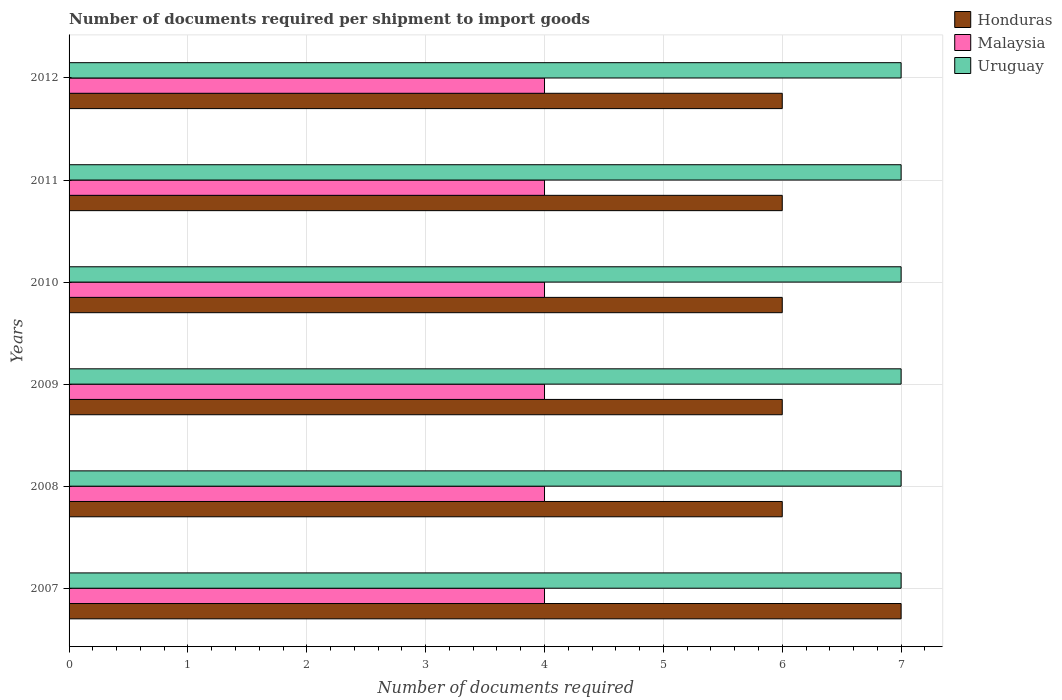How many different coloured bars are there?
Give a very brief answer. 3. Are the number of bars per tick equal to the number of legend labels?
Offer a very short reply. Yes. How many bars are there on the 2nd tick from the top?
Provide a succinct answer. 3. In how many cases, is the number of bars for a given year not equal to the number of legend labels?
Give a very brief answer. 0. What is the number of documents required per shipment to import goods in Malaysia in 2009?
Provide a succinct answer. 4. Across all years, what is the maximum number of documents required per shipment to import goods in Honduras?
Provide a short and direct response. 7. In which year was the number of documents required per shipment to import goods in Uruguay maximum?
Provide a succinct answer. 2007. In which year was the number of documents required per shipment to import goods in Honduras minimum?
Keep it short and to the point. 2008. What is the total number of documents required per shipment to import goods in Malaysia in the graph?
Ensure brevity in your answer.  24. What is the difference between the number of documents required per shipment to import goods in Honduras in 2008 and that in 2012?
Provide a succinct answer. 0. What is the difference between the number of documents required per shipment to import goods in Uruguay in 2010 and the number of documents required per shipment to import goods in Honduras in 2009?
Offer a terse response. 1. What is the average number of documents required per shipment to import goods in Uruguay per year?
Offer a terse response. 7. In the year 2011, what is the difference between the number of documents required per shipment to import goods in Malaysia and number of documents required per shipment to import goods in Honduras?
Ensure brevity in your answer.  -2. Is the difference between the number of documents required per shipment to import goods in Malaysia in 2009 and 2011 greater than the difference between the number of documents required per shipment to import goods in Honduras in 2009 and 2011?
Offer a very short reply. No. What is the difference between the highest and the lowest number of documents required per shipment to import goods in Honduras?
Your answer should be very brief. 1. Is the sum of the number of documents required per shipment to import goods in Uruguay in 2011 and 2012 greater than the maximum number of documents required per shipment to import goods in Honduras across all years?
Your response must be concise. Yes. What does the 1st bar from the top in 2010 represents?
Make the answer very short. Uruguay. What does the 1st bar from the bottom in 2007 represents?
Your answer should be very brief. Honduras. How many bars are there?
Offer a terse response. 18. Are all the bars in the graph horizontal?
Your answer should be compact. Yes. How many years are there in the graph?
Your response must be concise. 6. What is the difference between two consecutive major ticks on the X-axis?
Your answer should be very brief. 1. Are the values on the major ticks of X-axis written in scientific E-notation?
Your answer should be compact. No. Where does the legend appear in the graph?
Your answer should be compact. Top right. What is the title of the graph?
Your answer should be very brief. Number of documents required per shipment to import goods. Does "High income" appear as one of the legend labels in the graph?
Your answer should be compact. No. What is the label or title of the X-axis?
Your answer should be compact. Number of documents required. What is the Number of documents required of Honduras in 2007?
Give a very brief answer. 7. What is the Number of documents required of Uruguay in 2007?
Your answer should be compact. 7. What is the Number of documents required in Malaysia in 2008?
Your answer should be very brief. 4. What is the Number of documents required of Honduras in 2009?
Keep it short and to the point. 6. What is the Number of documents required in Malaysia in 2009?
Offer a terse response. 4. What is the Number of documents required in Uruguay in 2009?
Offer a terse response. 7. What is the Number of documents required of Malaysia in 2010?
Make the answer very short. 4. What is the Number of documents required in Uruguay in 2010?
Your answer should be compact. 7. What is the Number of documents required of Honduras in 2011?
Offer a terse response. 6. What is the Number of documents required in Malaysia in 2011?
Ensure brevity in your answer.  4. What is the Number of documents required in Uruguay in 2011?
Provide a short and direct response. 7. What is the Number of documents required of Malaysia in 2012?
Offer a very short reply. 4. What is the Number of documents required of Uruguay in 2012?
Make the answer very short. 7. Across all years, what is the maximum Number of documents required in Honduras?
Your answer should be very brief. 7. Across all years, what is the maximum Number of documents required in Malaysia?
Give a very brief answer. 4. Across all years, what is the minimum Number of documents required in Malaysia?
Your response must be concise. 4. What is the difference between the Number of documents required of Honduras in 2007 and that in 2008?
Your answer should be compact. 1. What is the difference between the Number of documents required of Malaysia in 2007 and that in 2008?
Give a very brief answer. 0. What is the difference between the Number of documents required in Uruguay in 2007 and that in 2008?
Your response must be concise. 0. What is the difference between the Number of documents required in Malaysia in 2007 and that in 2009?
Provide a short and direct response. 0. What is the difference between the Number of documents required of Uruguay in 2007 and that in 2009?
Offer a terse response. 0. What is the difference between the Number of documents required of Honduras in 2007 and that in 2010?
Provide a succinct answer. 1. What is the difference between the Number of documents required of Malaysia in 2007 and that in 2010?
Ensure brevity in your answer.  0. What is the difference between the Number of documents required in Honduras in 2007 and that in 2011?
Your answer should be very brief. 1. What is the difference between the Number of documents required of Malaysia in 2007 and that in 2011?
Your response must be concise. 0. What is the difference between the Number of documents required of Malaysia in 2007 and that in 2012?
Offer a very short reply. 0. What is the difference between the Number of documents required of Uruguay in 2007 and that in 2012?
Provide a short and direct response. 0. What is the difference between the Number of documents required of Honduras in 2008 and that in 2009?
Provide a short and direct response. 0. What is the difference between the Number of documents required of Uruguay in 2008 and that in 2009?
Provide a short and direct response. 0. What is the difference between the Number of documents required of Honduras in 2008 and that in 2010?
Make the answer very short. 0. What is the difference between the Number of documents required in Honduras in 2008 and that in 2011?
Offer a very short reply. 0. What is the difference between the Number of documents required in Uruguay in 2008 and that in 2011?
Offer a very short reply. 0. What is the difference between the Number of documents required in Malaysia in 2008 and that in 2012?
Keep it short and to the point. 0. What is the difference between the Number of documents required in Uruguay in 2008 and that in 2012?
Your answer should be very brief. 0. What is the difference between the Number of documents required of Malaysia in 2009 and that in 2010?
Your answer should be very brief. 0. What is the difference between the Number of documents required of Uruguay in 2009 and that in 2010?
Provide a short and direct response. 0. What is the difference between the Number of documents required in Malaysia in 2009 and that in 2011?
Your answer should be very brief. 0. What is the difference between the Number of documents required in Uruguay in 2009 and that in 2011?
Offer a very short reply. 0. What is the difference between the Number of documents required in Honduras in 2009 and that in 2012?
Give a very brief answer. 0. What is the difference between the Number of documents required of Honduras in 2010 and that in 2011?
Offer a terse response. 0. What is the difference between the Number of documents required of Malaysia in 2010 and that in 2011?
Keep it short and to the point. 0. What is the difference between the Number of documents required of Uruguay in 2010 and that in 2011?
Your answer should be compact. 0. What is the difference between the Number of documents required of Malaysia in 2010 and that in 2012?
Ensure brevity in your answer.  0. What is the difference between the Number of documents required of Uruguay in 2010 and that in 2012?
Provide a succinct answer. 0. What is the difference between the Number of documents required in Uruguay in 2011 and that in 2012?
Your answer should be compact. 0. What is the difference between the Number of documents required of Honduras in 2007 and the Number of documents required of Uruguay in 2008?
Give a very brief answer. 0. What is the difference between the Number of documents required of Honduras in 2007 and the Number of documents required of Malaysia in 2009?
Offer a terse response. 3. What is the difference between the Number of documents required of Honduras in 2007 and the Number of documents required of Uruguay in 2009?
Keep it short and to the point. 0. What is the difference between the Number of documents required of Honduras in 2007 and the Number of documents required of Malaysia in 2011?
Your response must be concise. 3. What is the difference between the Number of documents required of Malaysia in 2007 and the Number of documents required of Uruguay in 2011?
Provide a succinct answer. -3. What is the difference between the Number of documents required of Honduras in 2007 and the Number of documents required of Malaysia in 2012?
Offer a very short reply. 3. What is the difference between the Number of documents required of Honduras in 2008 and the Number of documents required of Uruguay in 2009?
Provide a succinct answer. -1. What is the difference between the Number of documents required in Honduras in 2008 and the Number of documents required in Uruguay in 2011?
Provide a succinct answer. -1. What is the difference between the Number of documents required in Malaysia in 2008 and the Number of documents required in Uruguay in 2011?
Your response must be concise. -3. What is the difference between the Number of documents required in Honduras in 2008 and the Number of documents required in Uruguay in 2012?
Your answer should be very brief. -1. What is the difference between the Number of documents required of Honduras in 2009 and the Number of documents required of Malaysia in 2010?
Give a very brief answer. 2. What is the difference between the Number of documents required in Honduras in 2009 and the Number of documents required in Uruguay in 2010?
Offer a terse response. -1. What is the difference between the Number of documents required of Malaysia in 2009 and the Number of documents required of Uruguay in 2011?
Your answer should be very brief. -3. What is the difference between the Number of documents required in Malaysia in 2009 and the Number of documents required in Uruguay in 2012?
Your answer should be compact. -3. What is the difference between the Number of documents required of Honduras in 2010 and the Number of documents required of Malaysia in 2011?
Offer a very short reply. 2. What is the difference between the Number of documents required in Malaysia in 2010 and the Number of documents required in Uruguay in 2011?
Offer a terse response. -3. What is the difference between the Number of documents required in Honduras in 2010 and the Number of documents required in Malaysia in 2012?
Your answer should be very brief. 2. What is the difference between the Number of documents required in Malaysia in 2010 and the Number of documents required in Uruguay in 2012?
Your answer should be very brief. -3. What is the difference between the Number of documents required of Honduras in 2011 and the Number of documents required of Uruguay in 2012?
Offer a terse response. -1. What is the average Number of documents required in Honduras per year?
Keep it short and to the point. 6.17. In the year 2007, what is the difference between the Number of documents required of Honduras and Number of documents required of Malaysia?
Give a very brief answer. 3. In the year 2007, what is the difference between the Number of documents required in Malaysia and Number of documents required in Uruguay?
Your answer should be very brief. -3. In the year 2009, what is the difference between the Number of documents required of Malaysia and Number of documents required of Uruguay?
Your response must be concise. -3. In the year 2010, what is the difference between the Number of documents required in Honduras and Number of documents required in Uruguay?
Provide a short and direct response. -1. In the year 2012, what is the difference between the Number of documents required in Honduras and Number of documents required in Malaysia?
Provide a succinct answer. 2. In the year 2012, what is the difference between the Number of documents required in Malaysia and Number of documents required in Uruguay?
Your answer should be very brief. -3. What is the ratio of the Number of documents required in Malaysia in 2007 to that in 2008?
Provide a succinct answer. 1. What is the ratio of the Number of documents required of Uruguay in 2007 to that in 2008?
Offer a very short reply. 1. What is the ratio of the Number of documents required in Honduras in 2007 to that in 2009?
Offer a very short reply. 1.17. What is the ratio of the Number of documents required in Malaysia in 2007 to that in 2010?
Offer a terse response. 1. What is the ratio of the Number of documents required in Uruguay in 2007 to that in 2010?
Your response must be concise. 1. What is the ratio of the Number of documents required in Uruguay in 2007 to that in 2011?
Your response must be concise. 1. What is the ratio of the Number of documents required in Honduras in 2008 to that in 2009?
Keep it short and to the point. 1. What is the ratio of the Number of documents required in Honduras in 2008 to that in 2010?
Give a very brief answer. 1. What is the ratio of the Number of documents required of Malaysia in 2008 to that in 2010?
Offer a terse response. 1. What is the ratio of the Number of documents required in Honduras in 2008 to that in 2011?
Offer a very short reply. 1. What is the ratio of the Number of documents required in Uruguay in 2008 to that in 2012?
Your response must be concise. 1. What is the ratio of the Number of documents required in Uruguay in 2009 to that in 2010?
Your answer should be compact. 1. What is the ratio of the Number of documents required in Malaysia in 2009 to that in 2012?
Keep it short and to the point. 1. What is the ratio of the Number of documents required of Malaysia in 2010 to that in 2011?
Provide a short and direct response. 1. What is the ratio of the Number of documents required of Uruguay in 2010 to that in 2011?
Give a very brief answer. 1. What is the ratio of the Number of documents required in Malaysia in 2010 to that in 2012?
Your response must be concise. 1. What is the difference between the highest and the second highest Number of documents required in Malaysia?
Provide a short and direct response. 0. What is the difference between the highest and the second highest Number of documents required in Uruguay?
Keep it short and to the point. 0. What is the difference between the highest and the lowest Number of documents required of Honduras?
Give a very brief answer. 1. What is the difference between the highest and the lowest Number of documents required of Malaysia?
Provide a short and direct response. 0. What is the difference between the highest and the lowest Number of documents required in Uruguay?
Offer a very short reply. 0. 